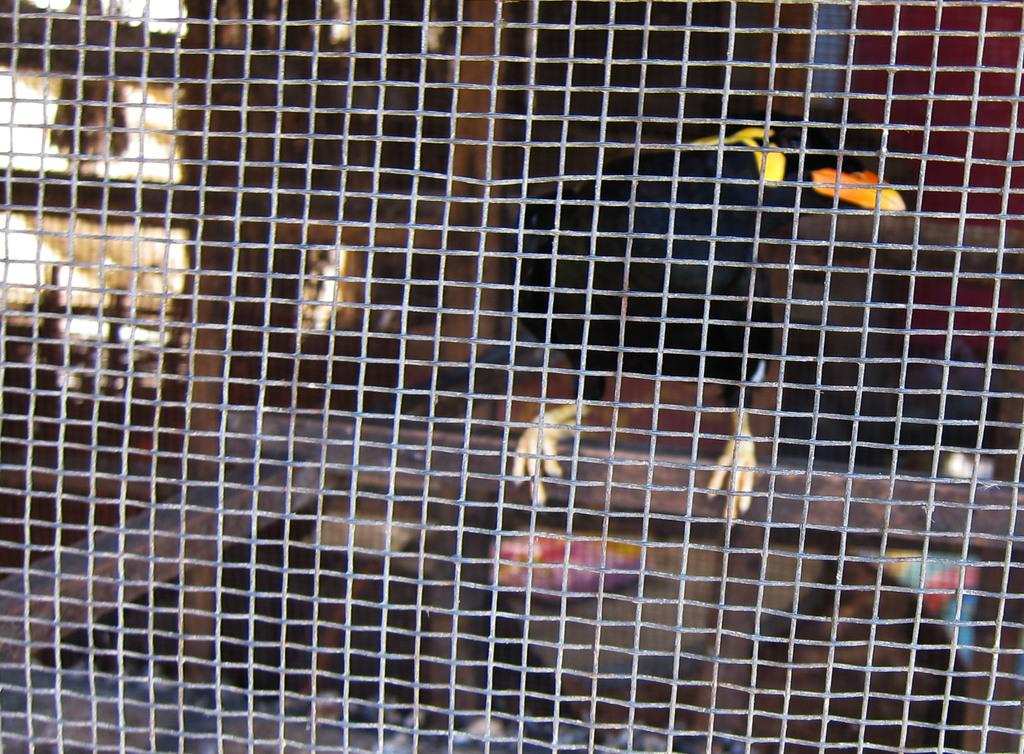What type of animal is present in the image? There is a bird in the image. Where is the bird located? The bird is in a cage. What type of bun is the bird holding in its beak in the image? There is no bun present in the image; the bird is in a cage. 